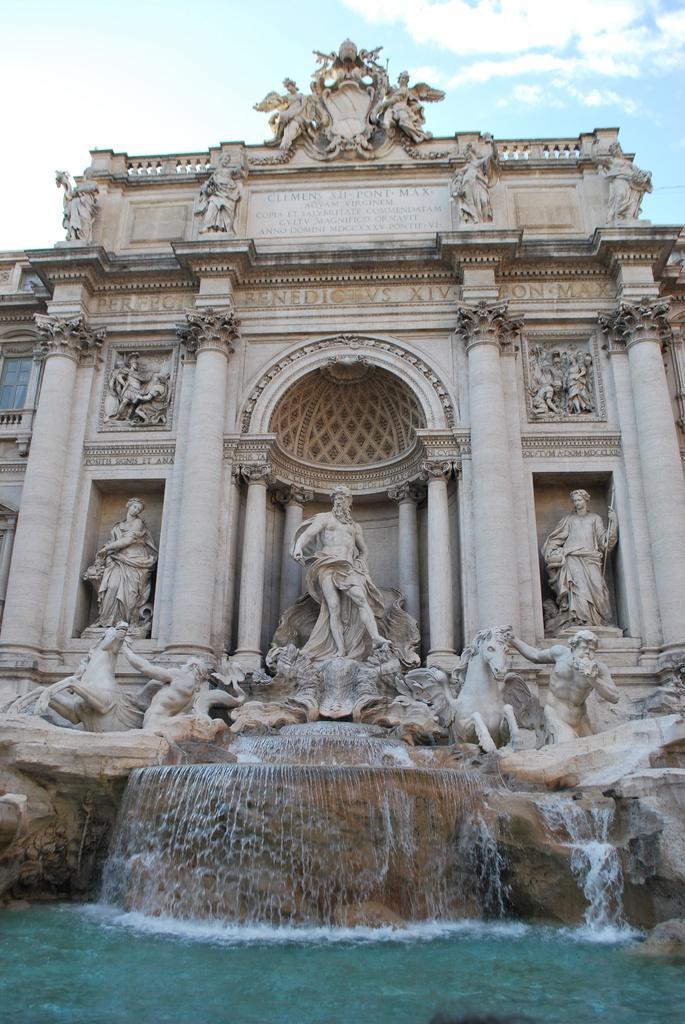Describe this image in one or two sentences. In the foreground of this image, there is a building and a waterfall. At the top, there is the sky and the cloud. 